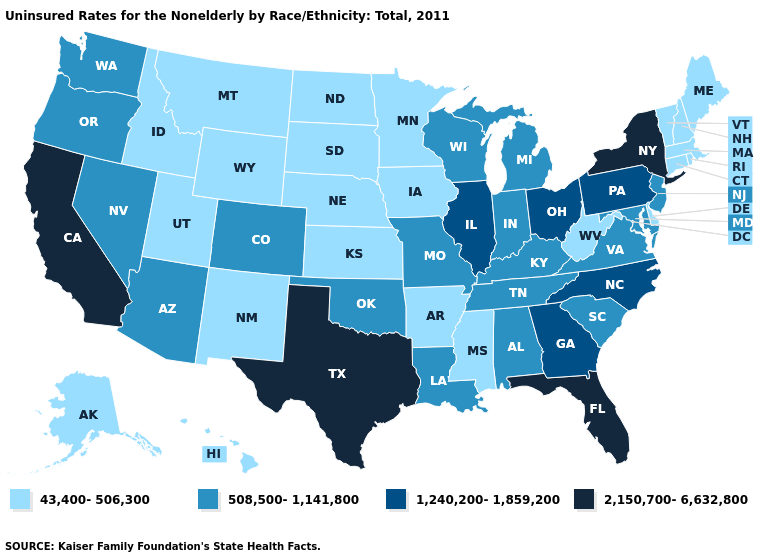What is the value of Nebraska?
Short answer required. 43,400-506,300. Does New Hampshire have a higher value than Wyoming?
Give a very brief answer. No. What is the value of Nebraska?
Concise answer only. 43,400-506,300. What is the highest value in the USA?
Keep it brief. 2,150,700-6,632,800. Does Alabama have the same value as Tennessee?
Short answer required. Yes. What is the value of Nevada?
Keep it brief. 508,500-1,141,800. Does the map have missing data?
Keep it brief. No. What is the value of North Carolina?
Concise answer only. 1,240,200-1,859,200. How many symbols are there in the legend?
Short answer required. 4. Name the states that have a value in the range 43,400-506,300?
Give a very brief answer. Alaska, Arkansas, Connecticut, Delaware, Hawaii, Idaho, Iowa, Kansas, Maine, Massachusetts, Minnesota, Mississippi, Montana, Nebraska, New Hampshire, New Mexico, North Dakota, Rhode Island, South Dakota, Utah, Vermont, West Virginia, Wyoming. Name the states that have a value in the range 2,150,700-6,632,800?
Answer briefly. California, Florida, New York, Texas. How many symbols are there in the legend?
Short answer required. 4. Which states hav the highest value in the Northeast?
Keep it brief. New York. What is the highest value in the USA?
Quick response, please. 2,150,700-6,632,800. 